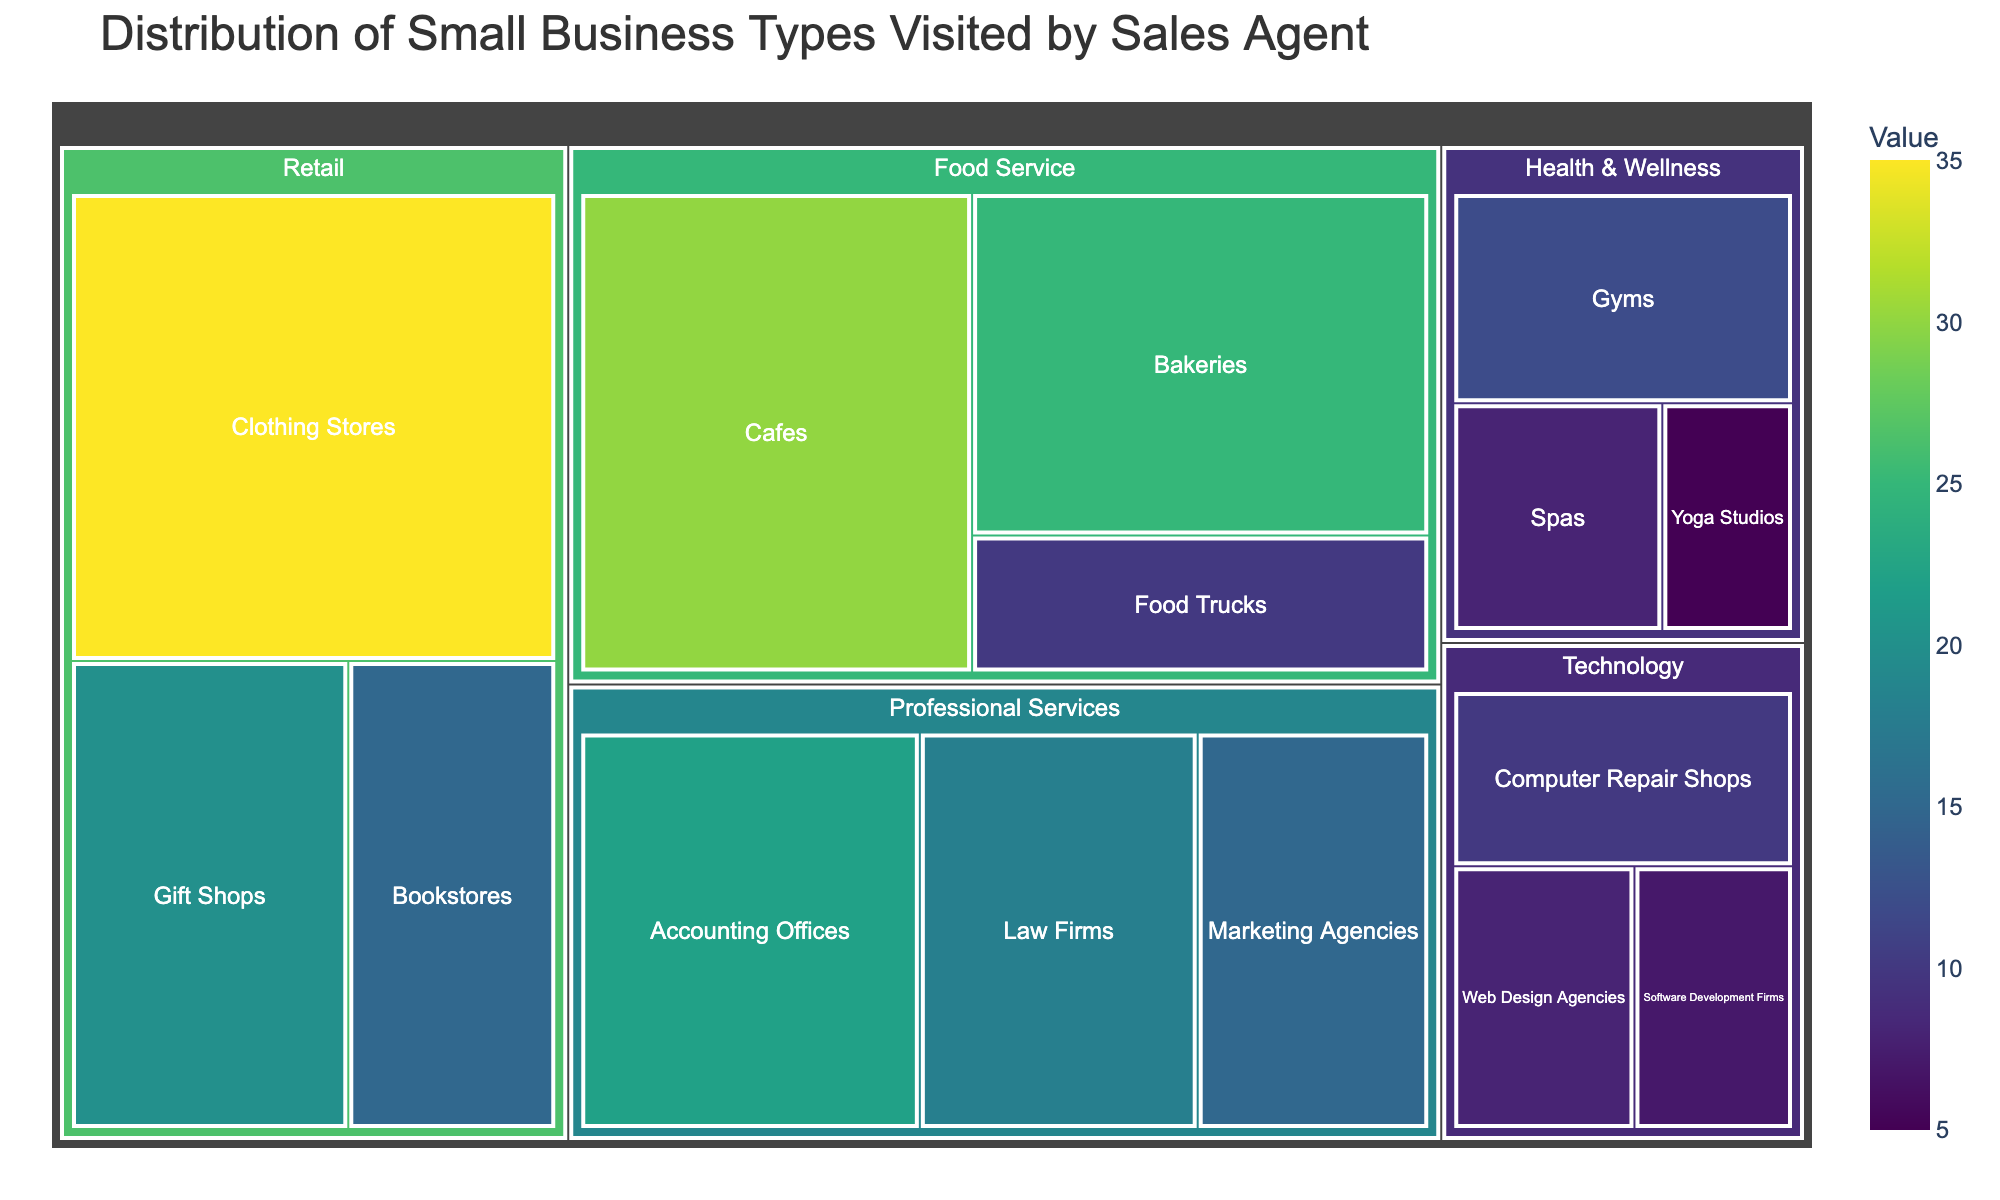Which category has the highest number of small businesses? Look for the category with the largest area in the treemap. The Retail category has the largest area, indicating it has the highest number of small businesses.
Answer: Retail What is the total number of businesses in the Food Service category? Sum the values of all subcategories within Food Service. Cafes (30) + Bakeries (25) + Food Trucks (10) = 65.
Answer: 65 Which subcategory within Professional Services has the lowest number of businesses? Within the Professional Services category, compare the areas of the subcategories. Marketing Agencies has the smallest area.
Answer: Marketing Agencies How many more Clothing Stores than Bookstores are there? Subtract the number of Bookstores from the number of Clothing Stores. Clothing Stores (35) - Bookstores (15) = 20.
Answer: 20 What is the combined total of businesses in the Health & Wellness category? Sum the values of all subcategories within Health & Wellness. Gyms (12) + Spas (8) + Yoga Studios (5) = 25.
Answer: 25 Which subcategory in Technology has the highest number of businesses? Within the Technology category, find the subcategory with the largest area. Computer Repair Shops have the largest area.
Answer: Computer Repair Shops Compare the total number of businesses in the Retail and Technology categories. Sum the values of subcategories within each category and compare. Retail: Clothing Stores (35) + Bookstores (15) + Gift Shops (20) = 70. Technology: Computer Repair Shops (10) + Web Design Agencies (8) + Software Development Firms (7) = 25. Retail has more businesses.
Answer: Retail What percentage of total businesses do Cafes represent in the Food Service category? Divide the number of Cafes by the total businesses in Food Service and multiply by 100. (30 / 65) * 100 ≈ 46.15%.
Answer: ~46.15% Identify two categories with a similar number of total businesses and specify the categories. Compare the total values across categories. Health & Wellness (25) and Technology (25) have the same total number of businesses.
Answer: Health & Wellness and Technology 